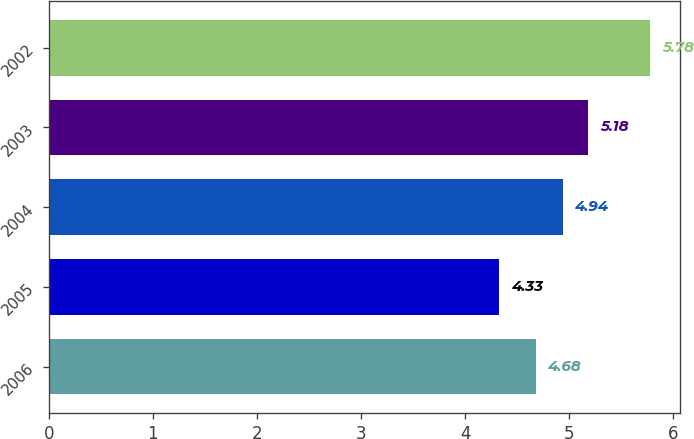Convert chart. <chart><loc_0><loc_0><loc_500><loc_500><bar_chart><fcel>2006<fcel>2005<fcel>2004<fcel>2003<fcel>2002<nl><fcel>4.68<fcel>4.33<fcel>4.94<fcel>5.18<fcel>5.78<nl></chart> 